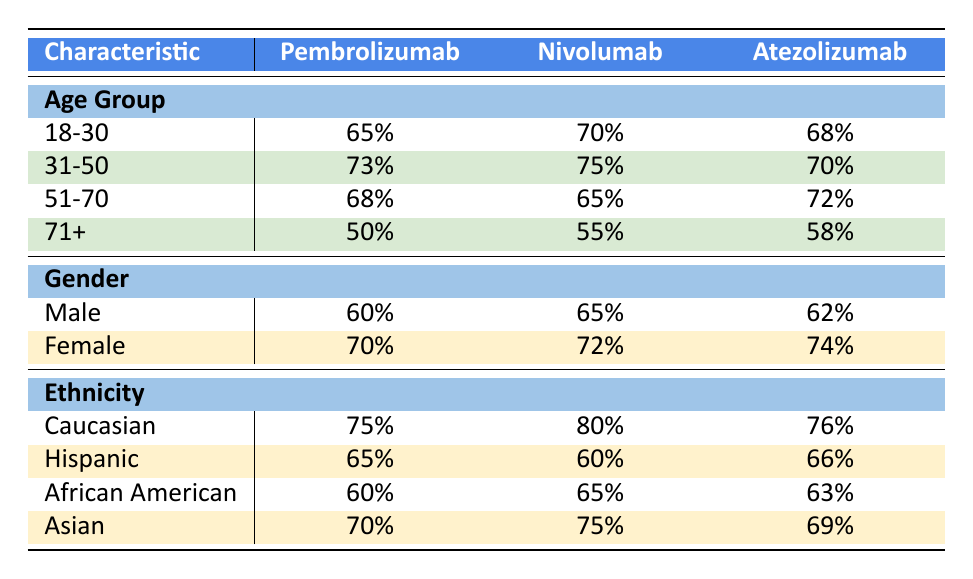What is the response rate for Pembrolizumab in the 31-50 age group? The table shows the response rates for Pembrolizumab by age group. For the 31-50 age group, the response rate listed is 73%.
Answer: 73% Which treatment has the highest response rate for females? By looking at the gender response rates for all treatments, Atezolizumab has the highest response rate for females at 74%.
Answer: 74% Is the response rate for Hispanic patients higher with Nivolumab or Atezolizumab? The response rate for Hispanic patients for Nivolumab is 60% and for Atezolizumab it is 66%. Since 66% is higher than 60%, Atezolizumab has the better response rate.
Answer: Atezolizumab What is the overall (average) response rate for male patients across all treatments? To find the average, we sum the response rates for males (60% + 65% + 62%) = 187%, and then divide by the number of treatments (3): 187% / 3 = 62.33%. Thus, the average response rate for male patients is approximately 62%.
Answer: 62% Is the response rate for African American patients the same for Pembrolizumab and Atezolizumab? The response rate for African American patients with Pembrolizumab is 60% and with Atezolizumab is 63%. Since these values are not equal, the response rates are not the same.
Answer: No Which treatment has the lowest response rate for patients aged 71 and older? The response rates at age 71+ are 50% for Pembrolizumab, 55% for Nivolumab, and 58% for Atezolizumab. The lowest of these is 50% for Pembrolizumab.
Answer: Pembrolizumab What is the difference in response rate between the oldest age group (71+) and the youngest age group (18-30) for Nivolumab? The response rate for Nivolumab in the 18-30 age group is 70%, while in the 71+ age group it is 55%. The difference is calculated as 70% - 55% = 15%.
Answer: 15% What gender has a better immunological treatment response rate in Atezolizumab? The response rate for males with Atezolizumab is 62% and for females, it is 74%. Since 74% is higher than 62%, females have the better response rate.
Answer: Females Which ethnic group has the highest response rate for Nivolumab? For Nivolumab, the response rates by ethnicity are: Caucasian 80%, Hispanic 60%, African American 65%, Asian 75%. The highest value here is 80% for the Caucasian group.
Answer: Caucasian 